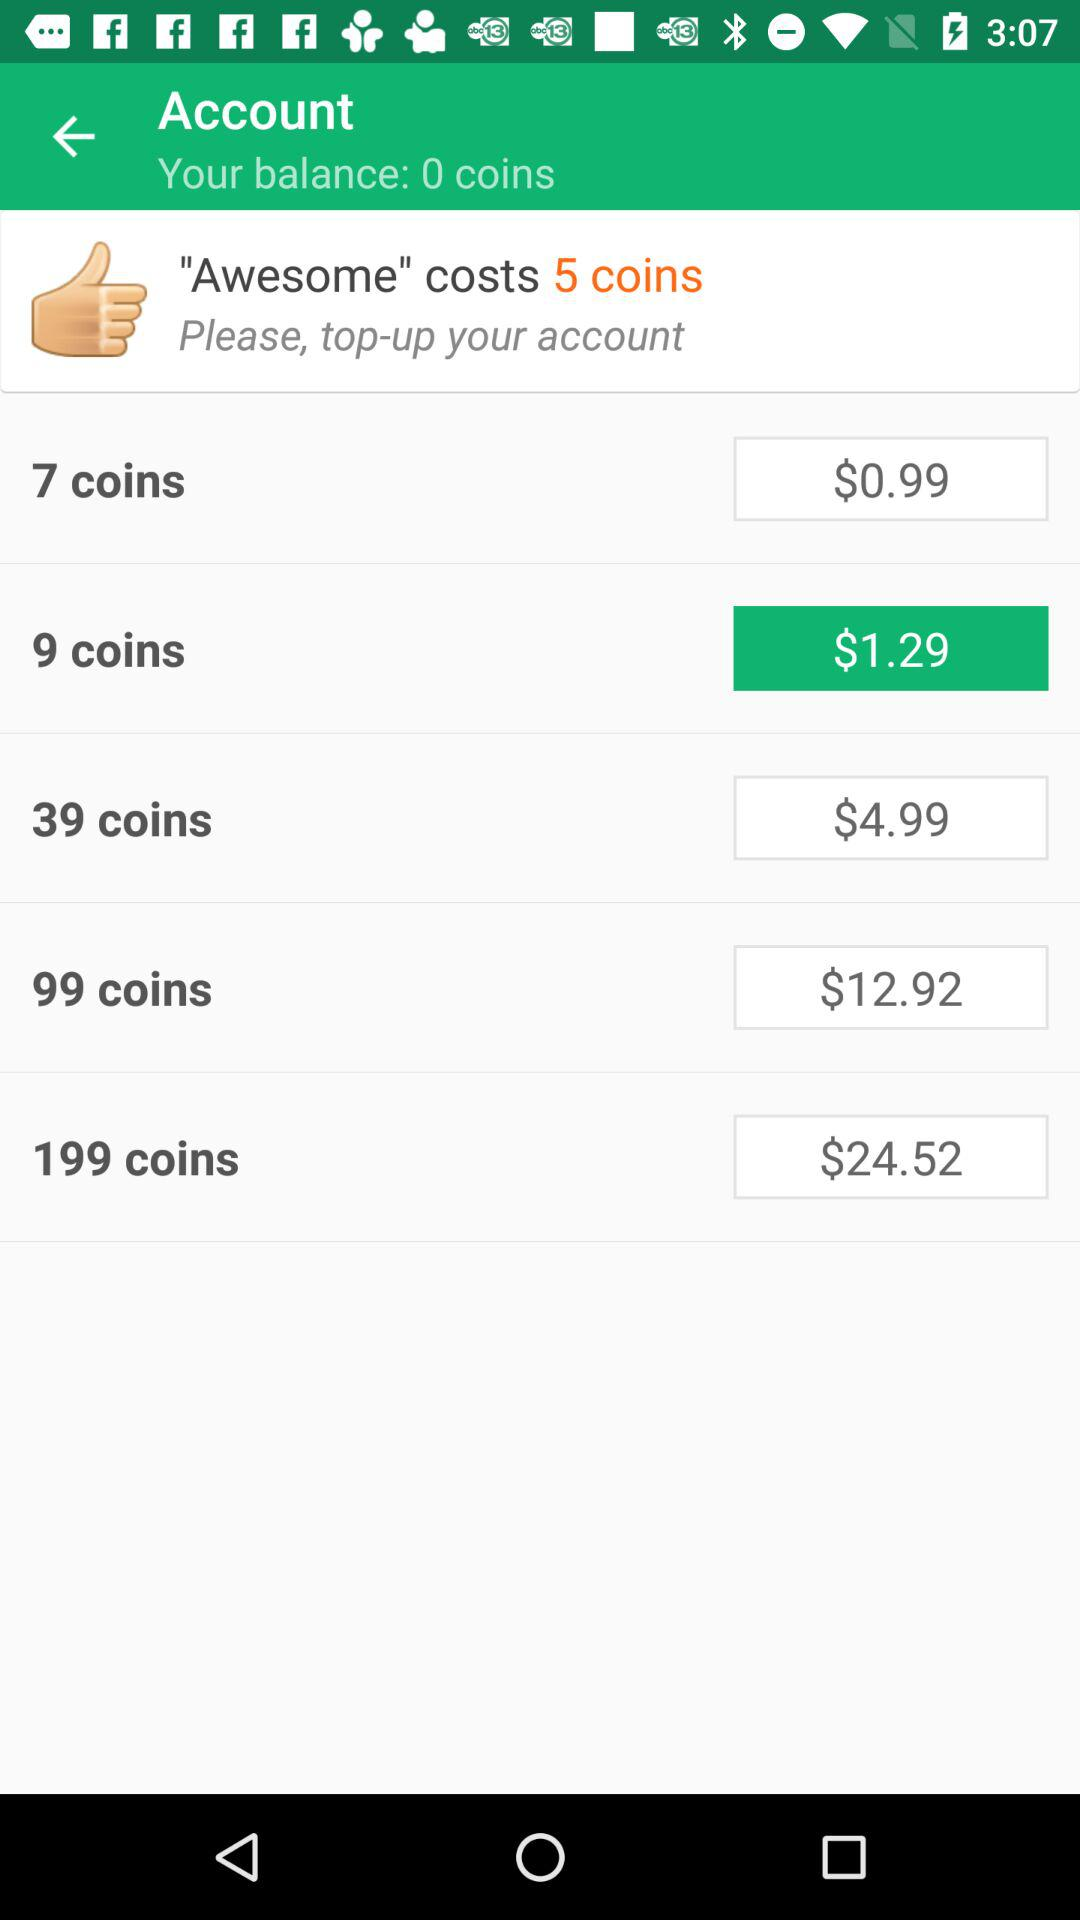How many coins are required to purchase the most expensive item? To purchase the most expensive item shown in the image, which costs 199 coins, you would need to top up your account with the corresponding amount of $24.52, as this is the price listed for obtaining 199 coins. 